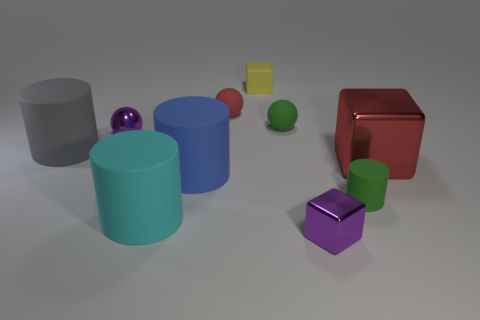How many other objects are the same shape as the large cyan rubber thing?
Offer a terse response. 3. Are there more large matte cylinders left of the big cyan thing than red cylinders?
Your answer should be compact. Yes. Are there any matte spheres of the same color as the large block?
Keep it short and to the point. Yes. What color is the shiny object that is the same size as the blue cylinder?
Provide a succinct answer. Red. How many tiny purple shiny objects are left of the large cylinder behind the blue cylinder?
Offer a very short reply. 0. What number of things are either spheres to the left of the tiny red ball or large brown metal things?
Ensure brevity in your answer.  1. How many tiny green cylinders are made of the same material as the large cyan cylinder?
Offer a very short reply. 1. What shape is the shiny thing that is the same color as the small metallic block?
Keep it short and to the point. Sphere. Is the number of small metallic balls that are behind the yellow block the same as the number of tiny cyan rubber cylinders?
Your answer should be very brief. Yes. There is a block to the right of the small matte cylinder; what is its size?
Provide a short and direct response. Large. 